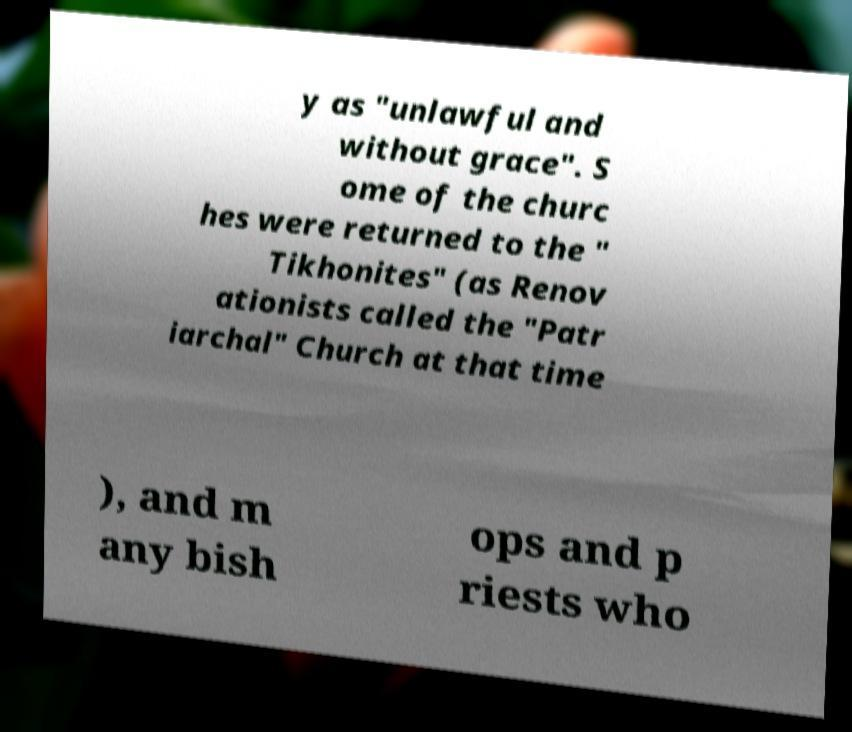There's text embedded in this image that I need extracted. Can you transcribe it verbatim? y as "unlawful and without grace". S ome of the churc hes were returned to the " Tikhonites" (as Renov ationists called the "Patr iarchal" Church at that time ), and m any bish ops and p riests who 